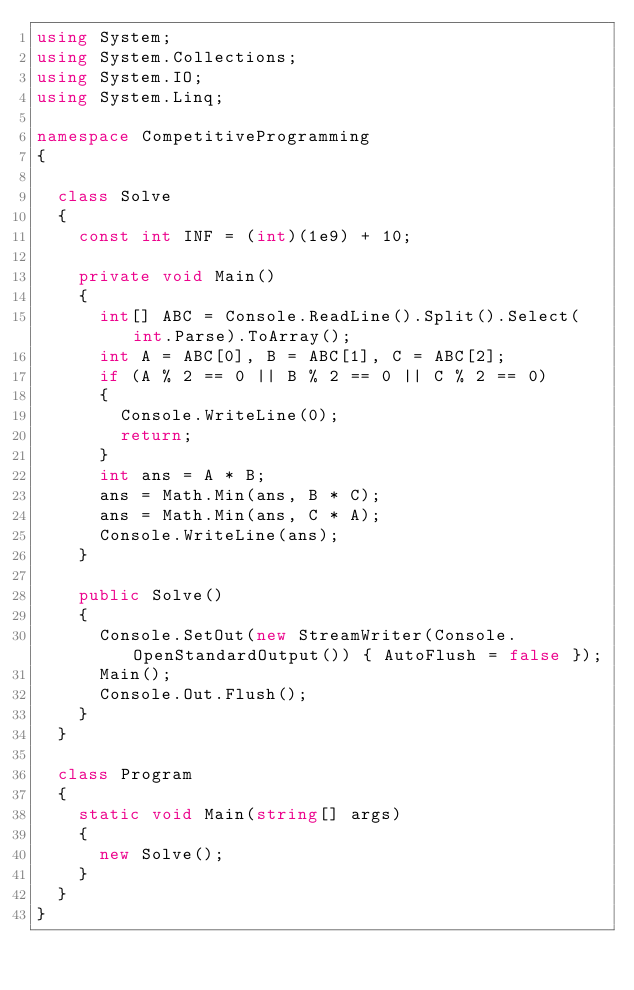<code> <loc_0><loc_0><loc_500><loc_500><_C#_>using System;
using System.Collections;
using System.IO;
using System.Linq;

namespace CompetitiveProgramming
{

  class Solve
  {
    const int INF = (int)(1e9) + 10;

    private void Main()
    {
      int[] ABC = Console.ReadLine().Split().Select(int.Parse).ToArray();
      int A = ABC[0], B = ABC[1], C = ABC[2];
      if (A % 2 == 0 || B % 2 == 0 || C % 2 == 0)
      {
        Console.WriteLine(0);
        return;
      }
      int ans = A * B;
      ans = Math.Min(ans, B * C);
      ans = Math.Min(ans, C * A);
      Console.WriteLine(ans);
    }

    public Solve()
    {
      Console.SetOut(new StreamWriter(Console.OpenStandardOutput()) { AutoFlush = false });
      Main();
      Console.Out.Flush();
    }
  }

  class Program
  {
    static void Main(string[] args)
    {
      new Solve();
    }
  }
}</code> 